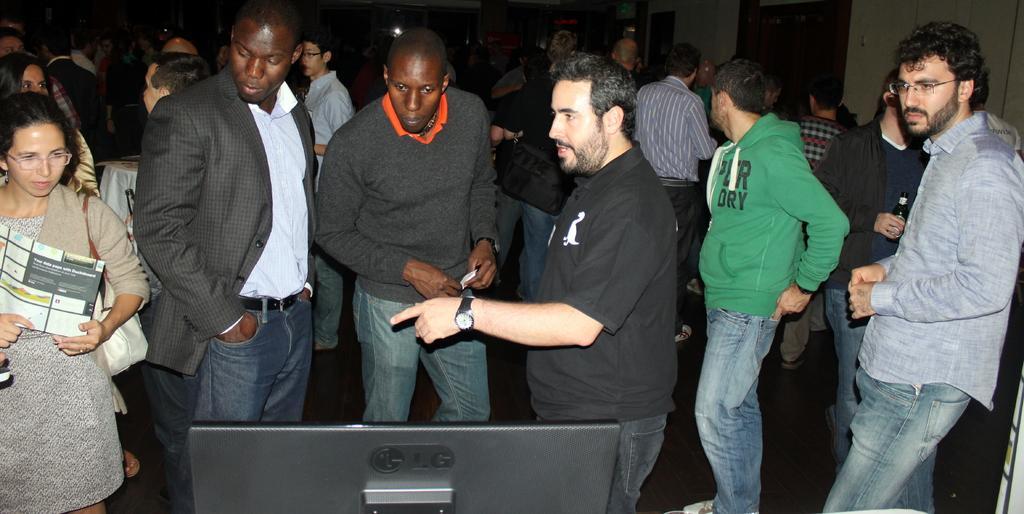Could you give a brief overview of what you see in this image? In this picture we can see a group of people standing on the floor, monitor, bottle, paper and in the background we can see the wall. 